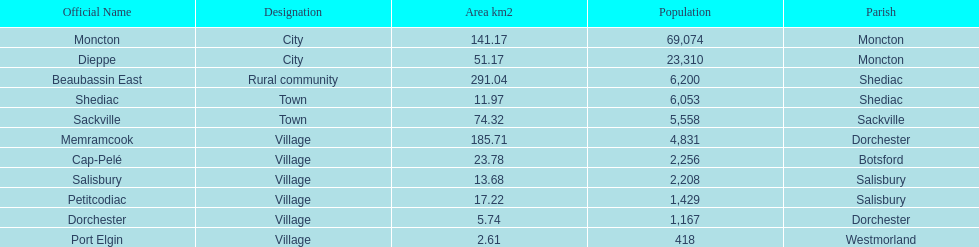How many municipalities have areas that are below 50 square kilometers? 6. 